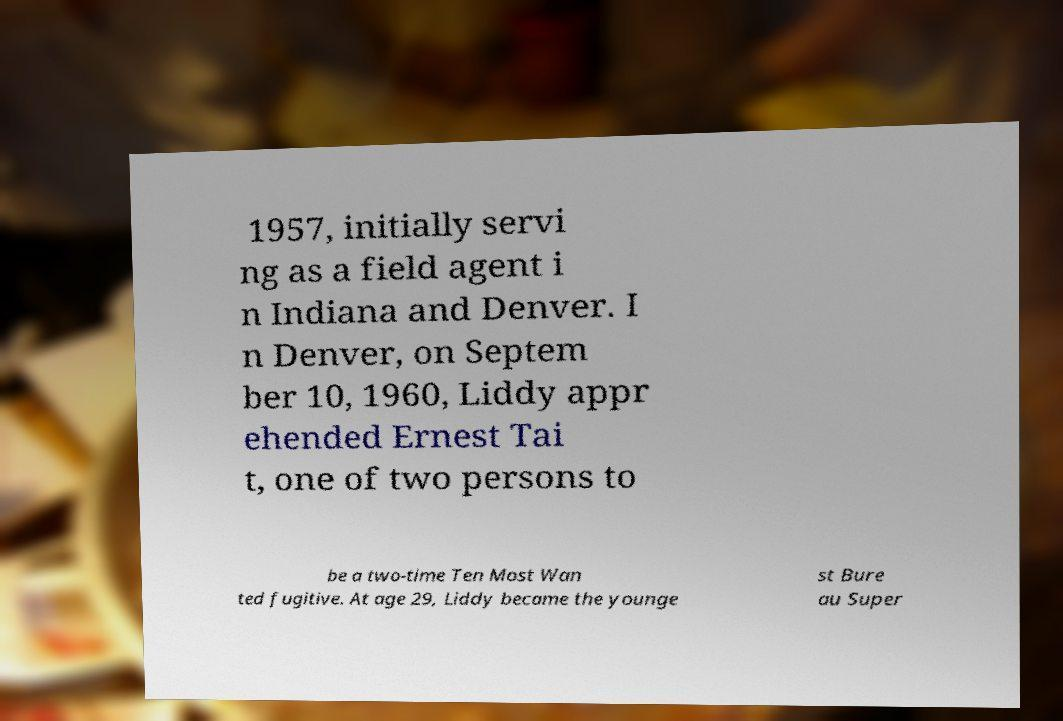For documentation purposes, I need the text within this image transcribed. Could you provide that? 1957, initially servi ng as a field agent i n Indiana and Denver. I n Denver, on Septem ber 10, 1960, Liddy appr ehended Ernest Tai t, one of two persons to be a two-time Ten Most Wan ted fugitive. At age 29, Liddy became the younge st Bure au Super 